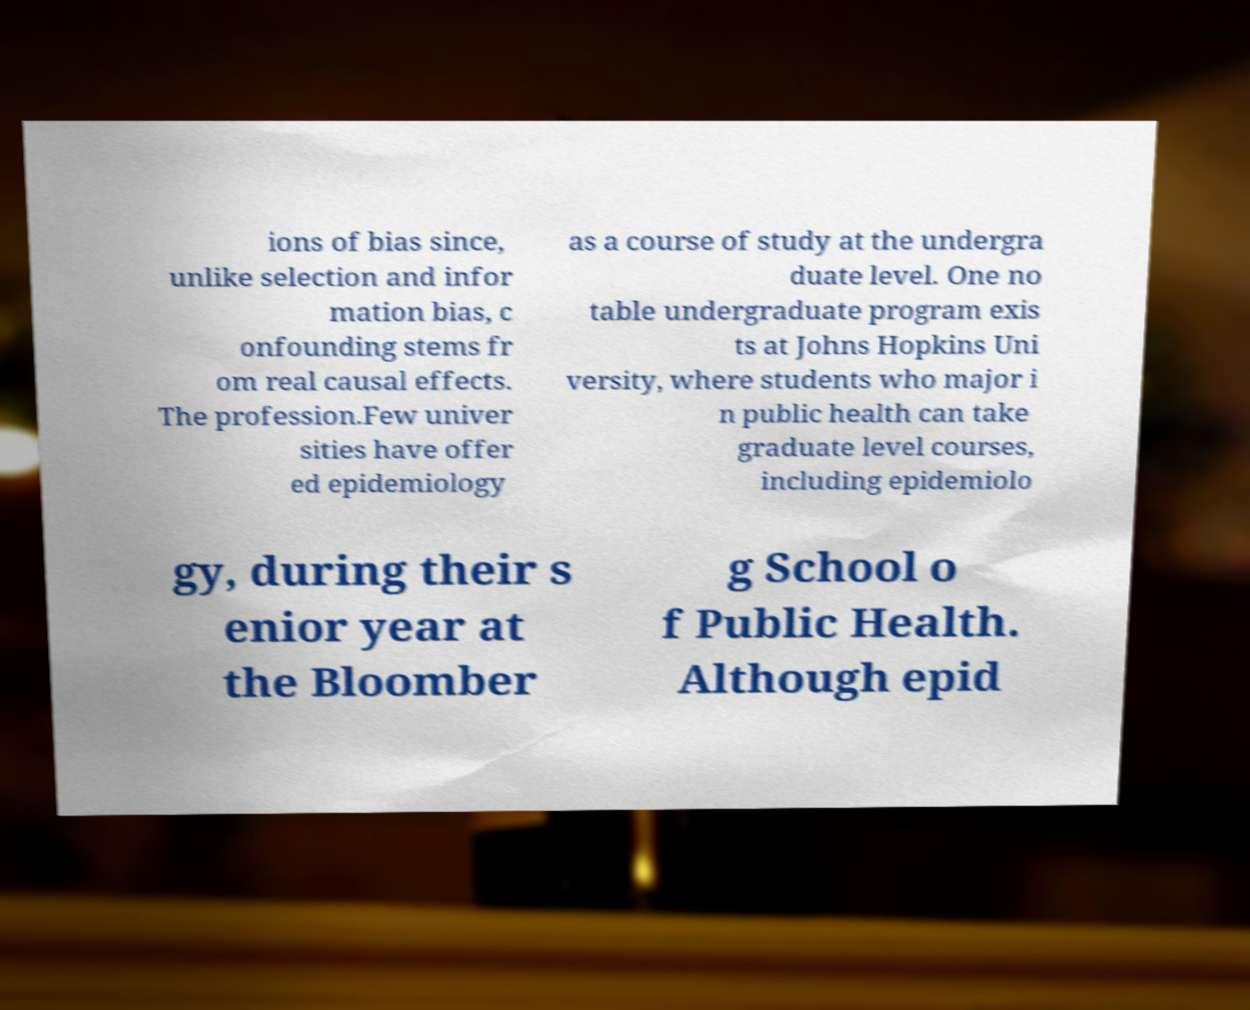I need the written content from this picture converted into text. Can you do that? ions of bias since, unlike selection and infor mation bias, c onfounding stems fr om real causal effects. The profession.Few univer sities have offer ed epidemiology as a course of study at the undergra duate level. One no table undergraduate program exis ts at Johns Hopkins Uni versity, where students who major i n public health can take graduate level courses, including epidemiolo gy, during their s enior year at the Bloomber g School o f Public Health. Although epid 